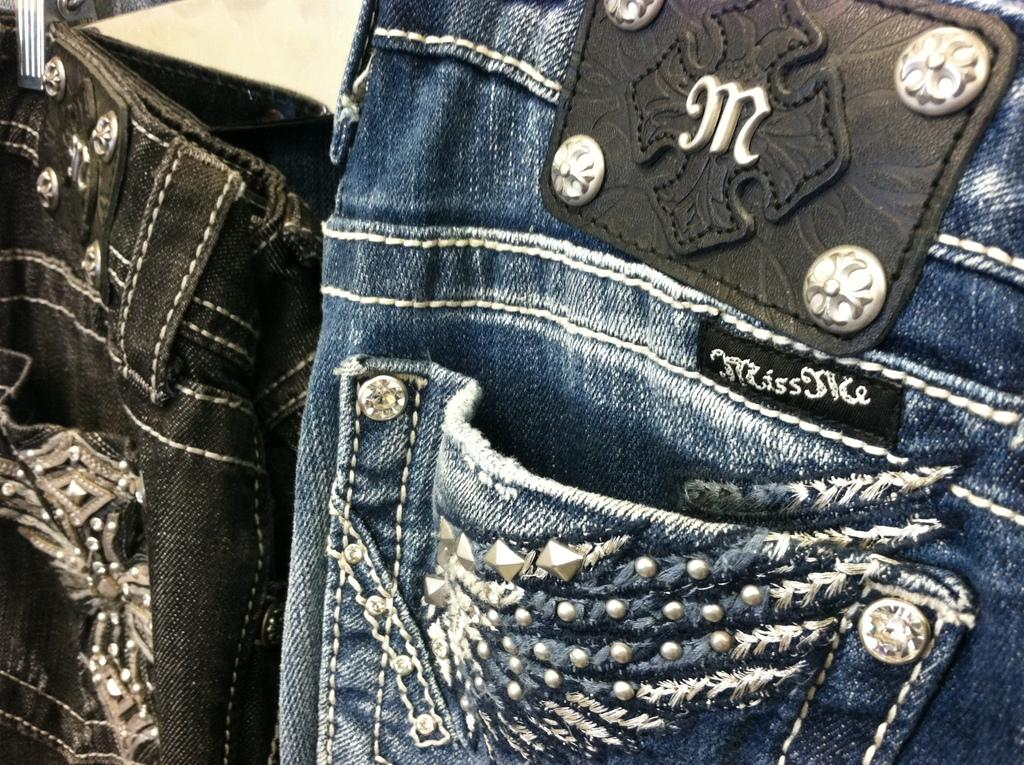What type of clothing is the focus of the image? The image is a zoomed in picture of a pair of jeans. What brand of toothpaste is visible on the jeans in the image? There is no toothpaste visible on the jeans in the image. 